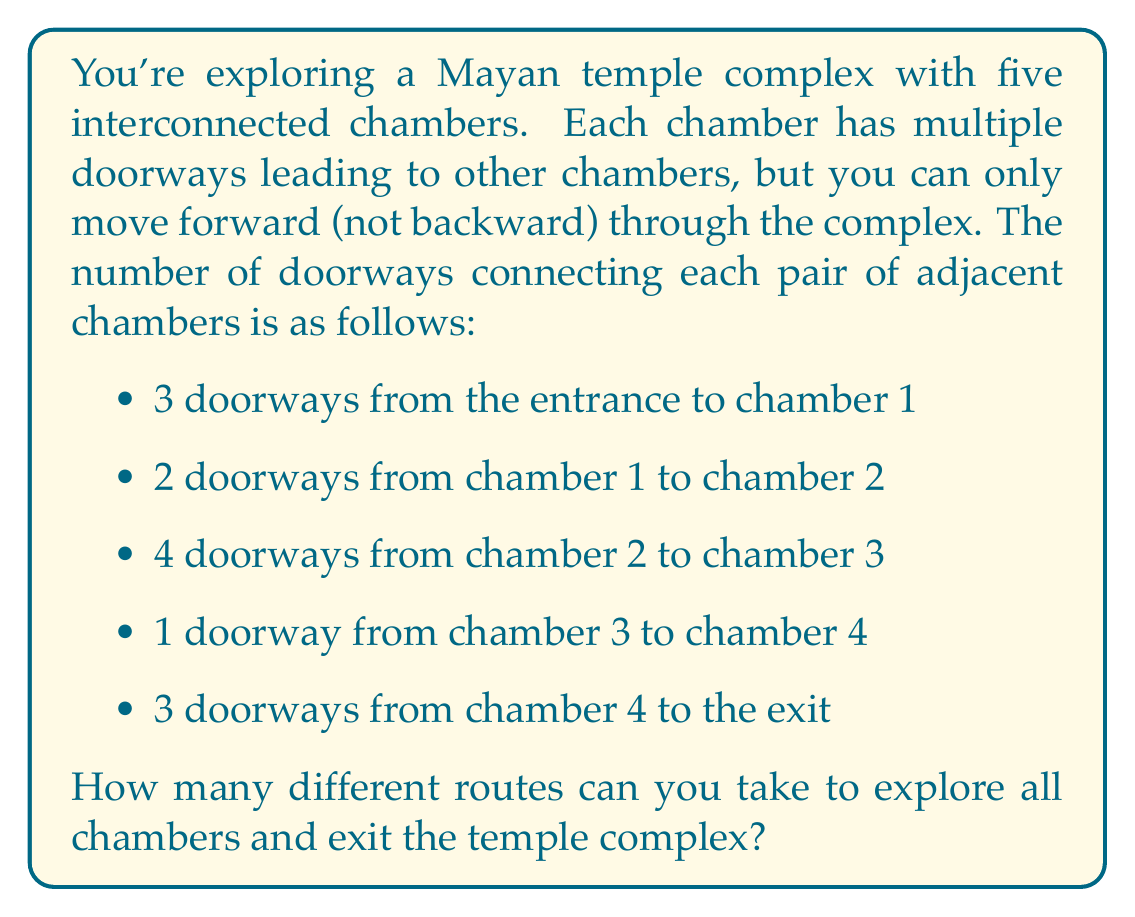Give your solution to this math problem. To solve this problem, we'll use the multiplication principle of counting. Since we can only move forward through the complex, we need to make a choice at each step of our journey. The total number of possible routes will be the product of the number of choices at each step.

Let's break it down:

1. From the entrance to chamber 1: 3 choices
2. From chamber 1 to chamber 2: 2 choices
3. From chamber 2 to chamber 3: 4 choices
4. From chamber 3 to chamber 4: 1 choice
5. From chamber 4 to the exit: 3 choices

Using the multiplication principle, we multiply these numbers together:

$$ \text{Total routes} = 3 \times 2 \times 4 \times 1 \times 3 $$

Calculating this:

$$ \text{Total routes} = 3 \times 2 \times 4 \times 1 \times 3 = 72 $$

Therefore, there are 72 different possible routes through the Mayan temple complex.
Answer: 72 routes 